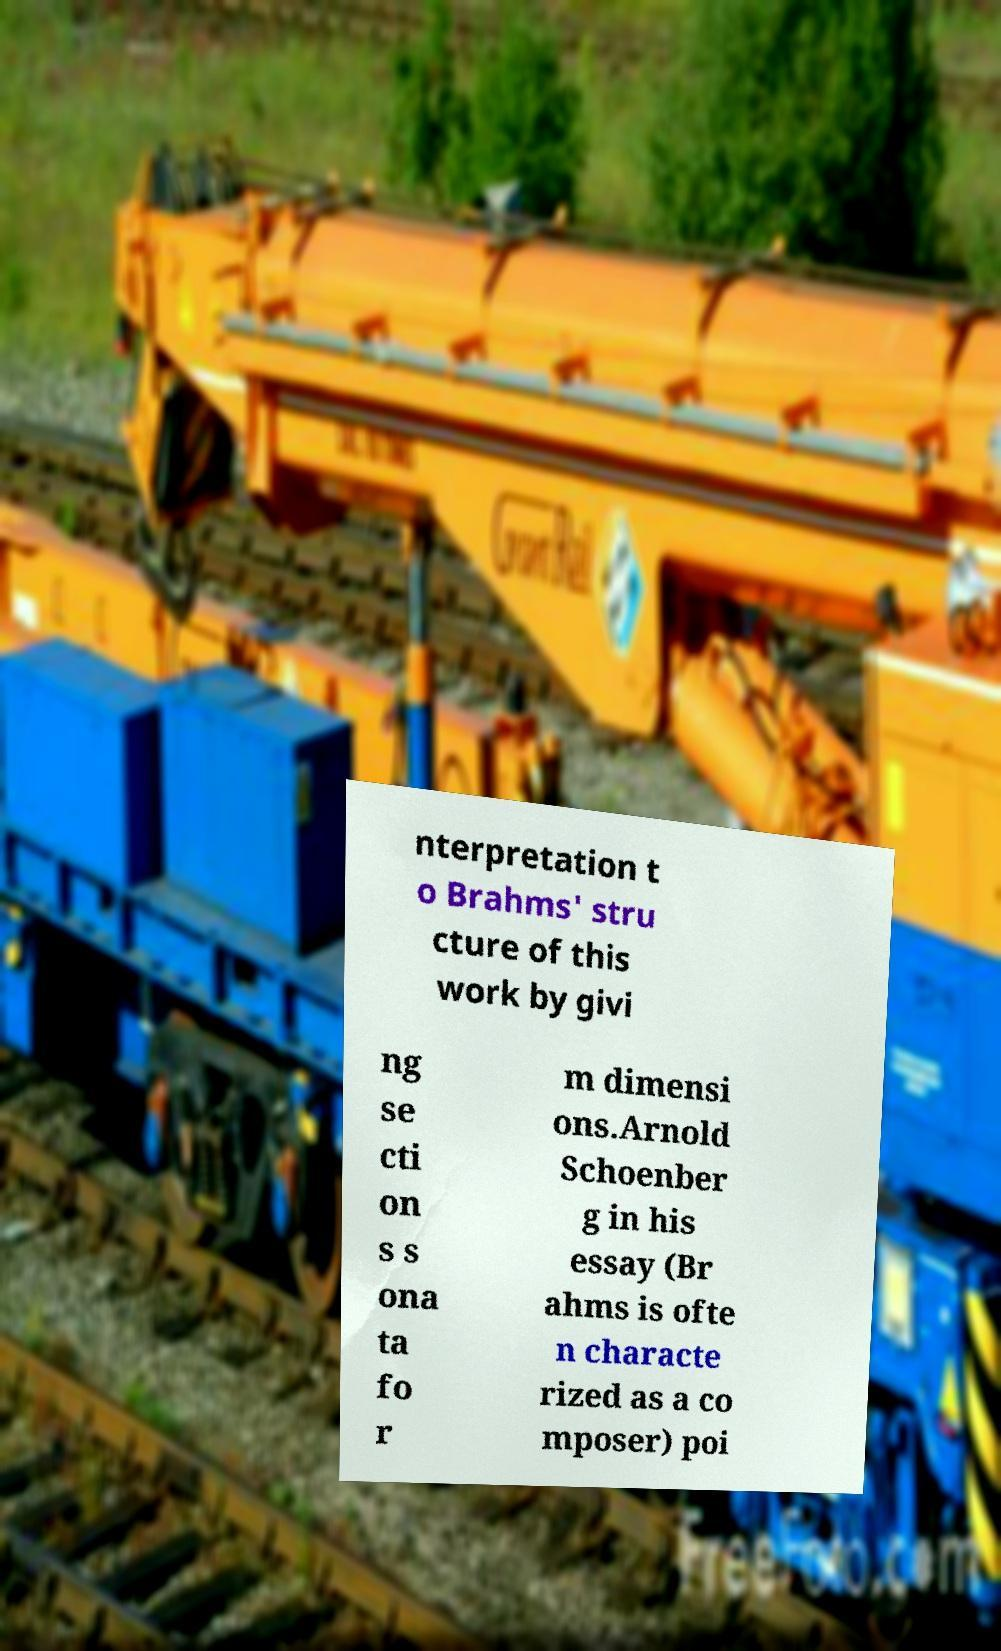What messages or text are displayed in this image? I need them in a readable, typed format. nterpretation t o Brahms' stru cture of this work by givi ng se cti on s s ona ta fo r m dimensi ons.Arnold Schoenber g in his essay (Br ahms is ofte n characte rized as a co mposer) poi 